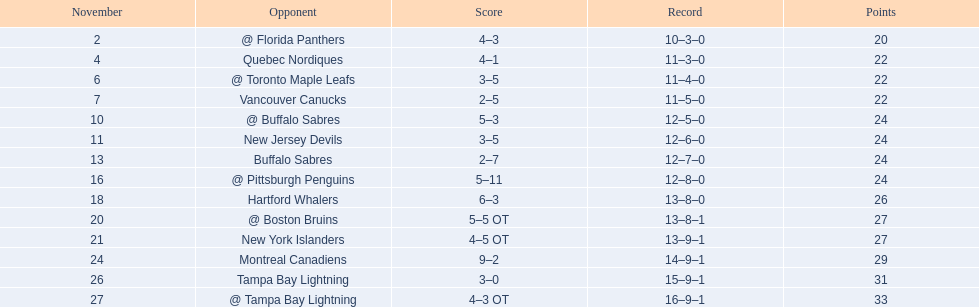What are the teams in the atlantic division? Quebec Nordiques, Vancouver Canucks, New Jersey Devils, Buffalo Sabres, Hartford Whalers, New York Islanders, Montreal Canadiens, Tampa Bay Lightning. Which of those scored fewer points than the philadelphia flyers? Tampa Bay Lightning. 